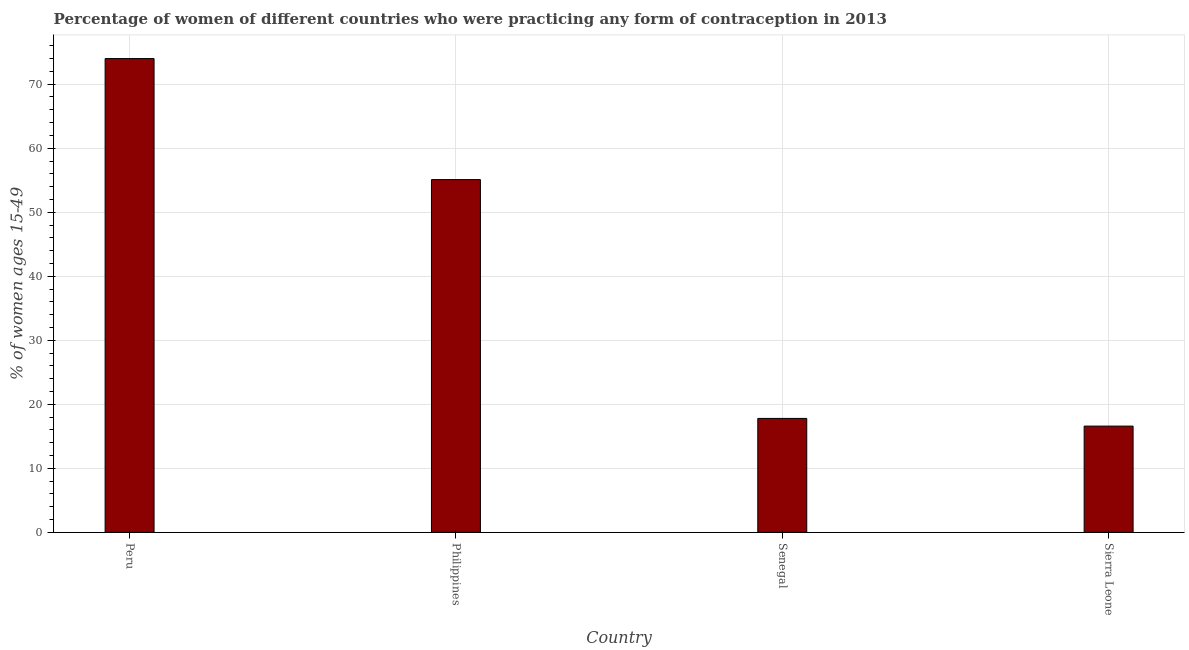Does the graph contain any zero values?
Ensure brevity in your answer.  No. Does the graph contain grids?
Your answer should be compact. Yes. What is the title of the graph?
Provide a succinct answer. Percentage of women of different countries who were practicing any form of contraception in 2013. What is the label or title of the X-axis?
Keep it short and to the point. Country. What is the label or title of the Y-axis?
Make the answer very short. % of women ages 15-49. Across all countries, what is the maximum contraceptive prevalence?
Your answer should be very brief. 74. In which country was the contraceptive prevalence minimum?
Your answer should be very brief. Sierra Leone. What is the sum of the contraceptive prevalence?
Provide a short and direct response. 163.5. What is the difference between the contraceptive prevalence in Peru and Senegal?
Your answer should be very brief. 56.2. What is the average contraceptive prevalence per country?
Your answer should be very brief. 40.88. What is the median contraceptive prevalence?
Give a very brief answer. 36.45. In how many countries, is the contraceptive prevalence greater than 58 %?
Provide a succinct answer. 1. What is the ratio of the contraceptive prevalence in Peru to that in Sierra Leone?
Ensure brevity in your answer.  4.46. Is the contraceptive prevalence in Peru less than that in Sierra Leone?
Your response must be concise. No. What is the difference between the highest and the second highest contraceptive prevalence?
Provide a succinct answer. 18.9. What is the difference between the highest and the lowest contraceptive prevalence?
Give a very brief answer. 57.4. How many bars are there?
Ensure brevity in your answer.  4. What is the difference between two consecutive major ticks on the Y-axis?
Offer a very short reply. 10. Are the values on the major ticks of Y-axis written in scientific E-notation?
Provide a succinct answer. No. What is the % of women ages 15-49 of Philippines?
Offer a very short reply. 55.1. What is the % of women ages 15-49 of Senegal?
Your answer should be compact. 17.8. What is the difference between the % of women ages 15-49 in Peru and Senegal?
Your answer should be very brief. 56.2. What is the difference between the % of women ages 15-49 in Peru and Sierra Leone?
Your response must be concise. 57.4. What is the difference between the % of women ages 15-49 in Philippines and Senegal?
Make the answer very short. 37.3. What is the difference between the % of women ages 15-49 in Philippines and Sierra Leone?
Provide a succinct answer. 38.5. What is the ratio of the % of women ages 15-49 in Peru to that in Philippines?
Offer a terse response. 1.34. What is the ratio of the % of women ages 15-49 in Peru to that in Senegal?
Offer a terse response. 4.16. What is the ratio of the % of women ages 15-49 in Peru to that in Sierra Leone?
Offer a very short reply. 4.46. What is the ratio of the % of women ages 15-49 in Philippines to that in Senegal?
Provide a succinct answer. 3.1. What is the ratio of the % of women ages 15-49 in Philippines to that in Sierra Leone?
Make the answer very short. 3.32. What is the ratio of the % of women ages 15-49 in Senegal to that in Sierra Leone?
Your answer should be very brief. 1.07. 